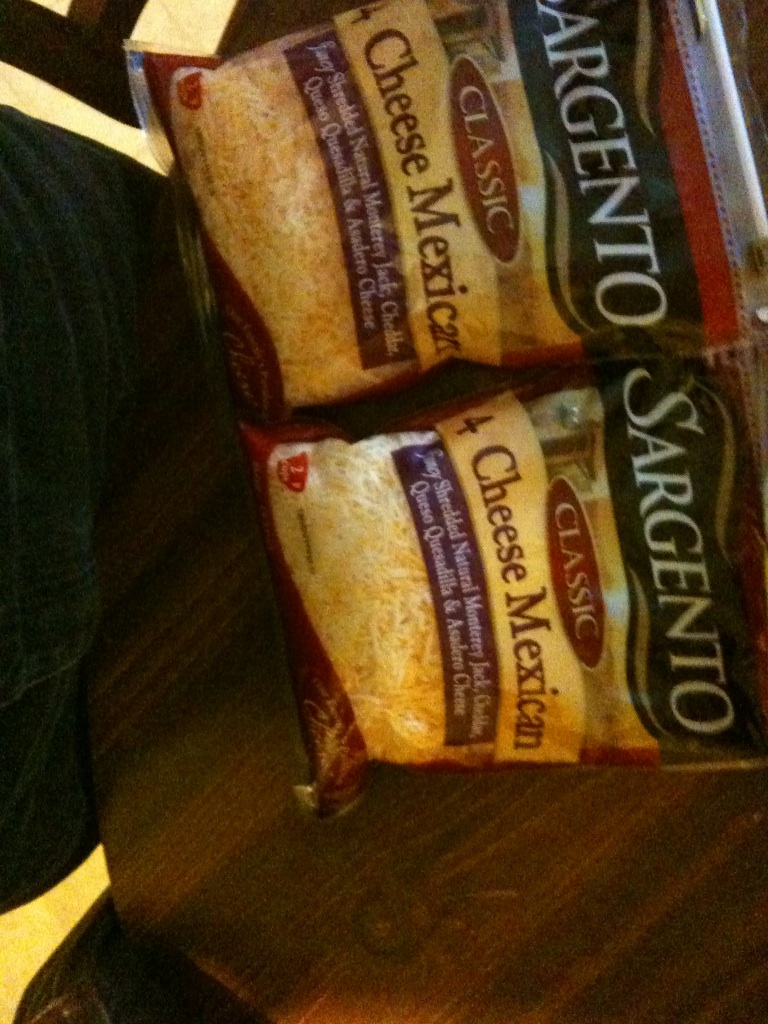Describe a realistic scenario where this cheese blend would be used at a family gathering. During a warm summer evening, a family gathers in the backyard for a barbecue. As the grill starts, the aroma of sizzling meat fills the air. The host brings out bowls of freshly grated Sargento Classic 4 Cheese Mexican blend. The children excitedly help sprinkle the cheese over a batch of homemade tortilla chips, creating gooey, cheesy nachos. Meanwhile, others use the cheese to stuff and top grilled bell peppers. The result is a delicious, gooey, spicy feast that brings everyone together, laughing and sharing stories well into the night.  What if this cheese blend was found at a magical marketplace? Describe what might happen! In the heart of a bustling magical marketplace, amidst potion sellers and mythical creature vendors, lies a humble cheese stall. The Sargento Classic 4 Cheese Mexican blend is said to have enchanting properties. Each cheese in the blend contributes to a unique spell:
- The **Monterey Jack** enhances calm and clarity of thought.
- **Cheddar** sharpens the mind and wit.
- **Queso Quesadilla** brings warmth and comfort to hearts.
- **Asadero** unlocks creativity and imagination.
Adventurers seek this blend to craft a powerful enchantment that once sprinkled on a dish, creates a meal that satisfies the soul and unites all who partake under a temporary bond of friendship and harmony. 